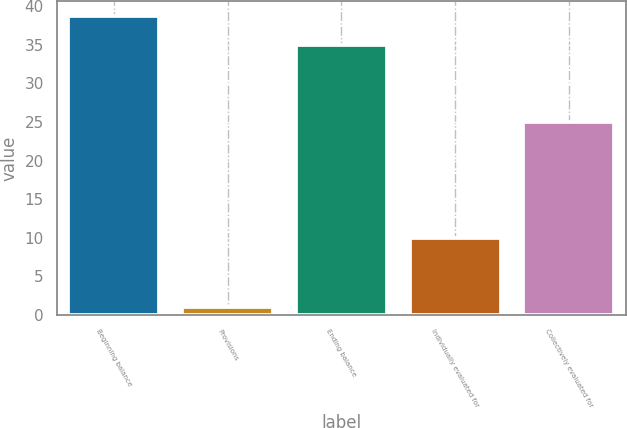<chart> <loc_0><loc_0><loc_500><loc_500><bar_chart><fcel>Beginning balance<fcel>Provisions<fcel>Ending balance<fcel>Individually evaluated for<fcel>Collectively evaluated for<nl><fcel>38.7<fcel>1<fcel>35<fcel>10<fcel>25<nl></chart> 